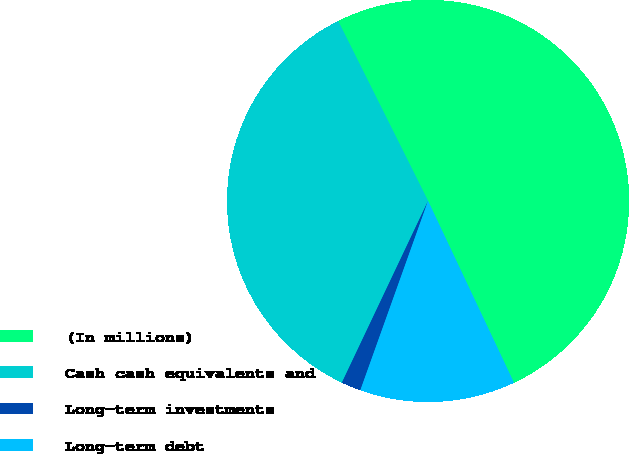Convert chart to OTSL. <chart><loc_0><loc_0><loc_500><loc_500><pie_chart><fcel>(In millions)<fcel>Cash cash equivalents and<fcel>Long-term investments<fcel>Long-term debt<nl><fcel>50.35%<fcel>35.58%<fcel>1.58%<fcel>12.49%<nl></chart> 